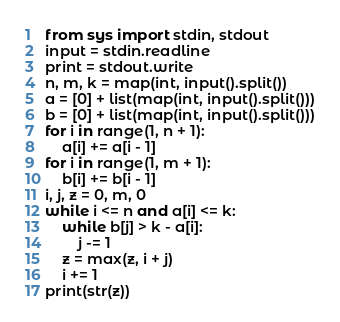<code> <loc_0><loc_0><loc_500><loc_500><_Python_>from sys import stdin, stdout
input = stdin.readline
print = stdout.write
n, m, k = map(int, input().split())
a = [0] + list(map(int, input().split()))
b = [0] + list(map(int, input().split()))
for i in range(1, n + 1):
    a[i] += a[i - 1]
for i in range(1, m + 1):
    b[i] += b[i - 1]
i, j, z = 0, m, 0
while i <= n and a[i] <= k:
    while b[j] > k - a[i]:
        j -= 1
    z = max(z, i + j)
    i += 1
print(str(z))</code> 